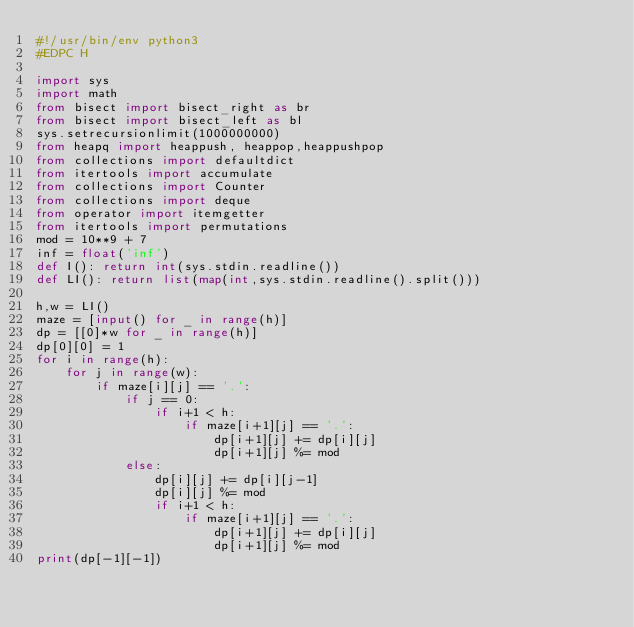Convert code to text. <code><loc_0><loc_0><loc_500><loc_500><_Python_>#!/usr/bin/env python3
#EDPC H

import sys
import math
from bisect import bisect_right as br
from bisect import bisect_left as bl
sys.setrecursionlimit(1000000000)
from heapq import heappush, heappop,heappushpop
from collections import defaultdict
from itertools import accumulate
from collections import Counter
from collections import deque
from operator import itemgetter
from itertools import permutations
mod = 10**9 + 7
inf = float('inf')
def I(): return int(sys.stdin.readline())
def LI(): return list(map(int,sys.stdin.readline().split()))

h,w = LI()
maze = [input() for _ in range(h)]
dp = [[0]*w for _ in range(h)]
dp[0][0] = 1
for i in range(h):
    for j in range(w):
        if maze[i][j] == '.':
            if j == 0:
                if i+1 < h:
                    if maze[i+1][j] == '.':
                        dp[i+1][j] += dp[i][j]
                        dp[i+1][j] %= mod
            else:
                dp[i][j] += dp[i][j-1]
                dp[i][j] %= mod
                if i+1 < h:
                    if maze[i+1][j] == '.':
                        dp[i+1][j] += dp[i][j]
                        dp[i+1][j] %= mod
print(dp[-1][-1])                   
    
</code> 